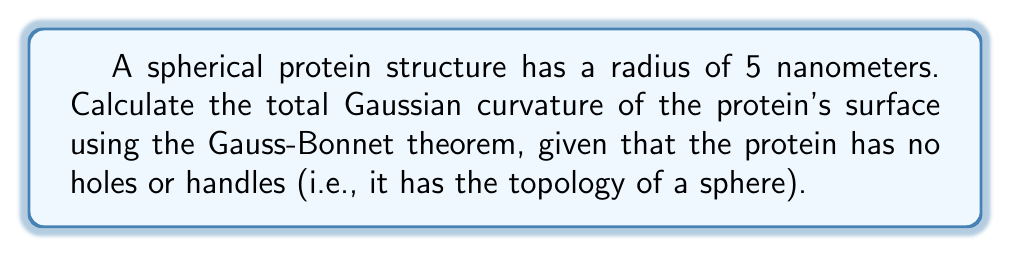Solve this math problem. To solve this problem, we'll follow these steps:

1) First, recall the Gauss-Bonnet theorem for a closed surface:

   $$\iint_S K dA = 2\pi\chi(S)$$

   where $K$ is the Gaussian curvature, $dA$ is the area element, and $\chi(S)$ is the Euler characteristic of the surface.

2) For a sphere, the Euler characteristic $\chi(S) = 2$.

3) Therefore, the total Gaussian curvature of a sphere is:

   $$\iint_S K dA = 2\pi(2) = 4\pi$$

4) Note that this result is independent of the radius of the sphere. This is because the Gaussian curvature is an intrinsic property of the surface and doesn't depend on how the surface is embedded in 3D space.

5) Although not necessary for the final answer, we can calculate the Gaussian curvature at any point on a sphere of radius $r$:

   $$K = \frac{1}{r^2}$$

   For our protein with radius 5 nm, the Gaussian curvature at any point would be:

   $$K = \frac{1}{(5\text{ nm})^2} = 0.04 \text{ nm}^{-2}$$

6) The surface area of this sphere would be:

   $$A = 4\pi r^2 = 4\pi(5\text{ nm})^2 = 100\pi \text{ nm}^2$$

However, these last two calculations are not necessary for determining the total Gaussian curvature, which remains $4\pi$ regardless of the sphere's size.
Answer: $4\pi$ 